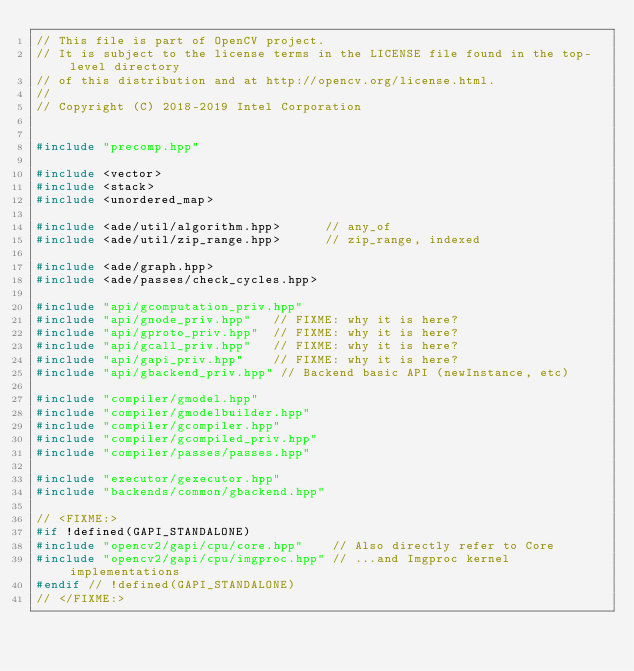Convert code to text. <code><loc_0><loc_0><loc_500><loc_500><_C++_>// This file is part of OpenCV project.
// It is subject to the license terms in the LICENSE file found in the top-level directory
// of this distribution and at http://opencv.org/license.html.
//
// Copyright (C) 2018-2019 Intel Corporation


#include "precomp.hpp"

#include <vector>
#include <stack>
#include <unordered_map>

#include <ade/util/algorithm.hpp>      // any_of
#include <ade/util/zip_range.hpp>      // zip_range, indexed

#include <ade/graph.hpp>
#include <ade/passes/check_cycles.hpp>

#include "api/gcomputation_priv.hpp"
#include "api/gnode_priv.hpp"   // FIXME: why it is here?
#include "api/gproto_priv.hpp"  // FIXME: why it is here?
#include "api/gcall_priv.hpp"   // FIXME: why it is here?
#include "api/gapi_priv.hpp"    // FIXME: why it is here?
#include "api/gbackend_priv.hpp" // Backend basic API (newInstance, etc)

#include "compiler/gmodel.hpp"
#include "compiler/gmodelbuilder.hpp"
#include "compiler/gcompiler.hpp"
#include "compiler/gcompiled_priv.hpp"
#include "compiler/passes/passes.hpp"

#include "executor/gexecutor.hpp"
#include "backends/common/gbackend.hpp"

// <FIXME:>
#if !defined(GAPI_STANDALONE)
#include "opencv2/gapi/cpu/core.hpp"    // Also directly refer to Core
#include "opencv2/gapi/cpu/imgproc.hpp" // ...and Imgproc kernel implementations
#endif // !defined(GAPI_STANDALONE)
// </FIXME:>
</code> 